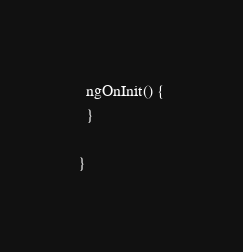<code> <loc_0><loc_0><loc_500><loc_500><_TypeScript_>
  ngOnInit() {
  }

}
</code> 